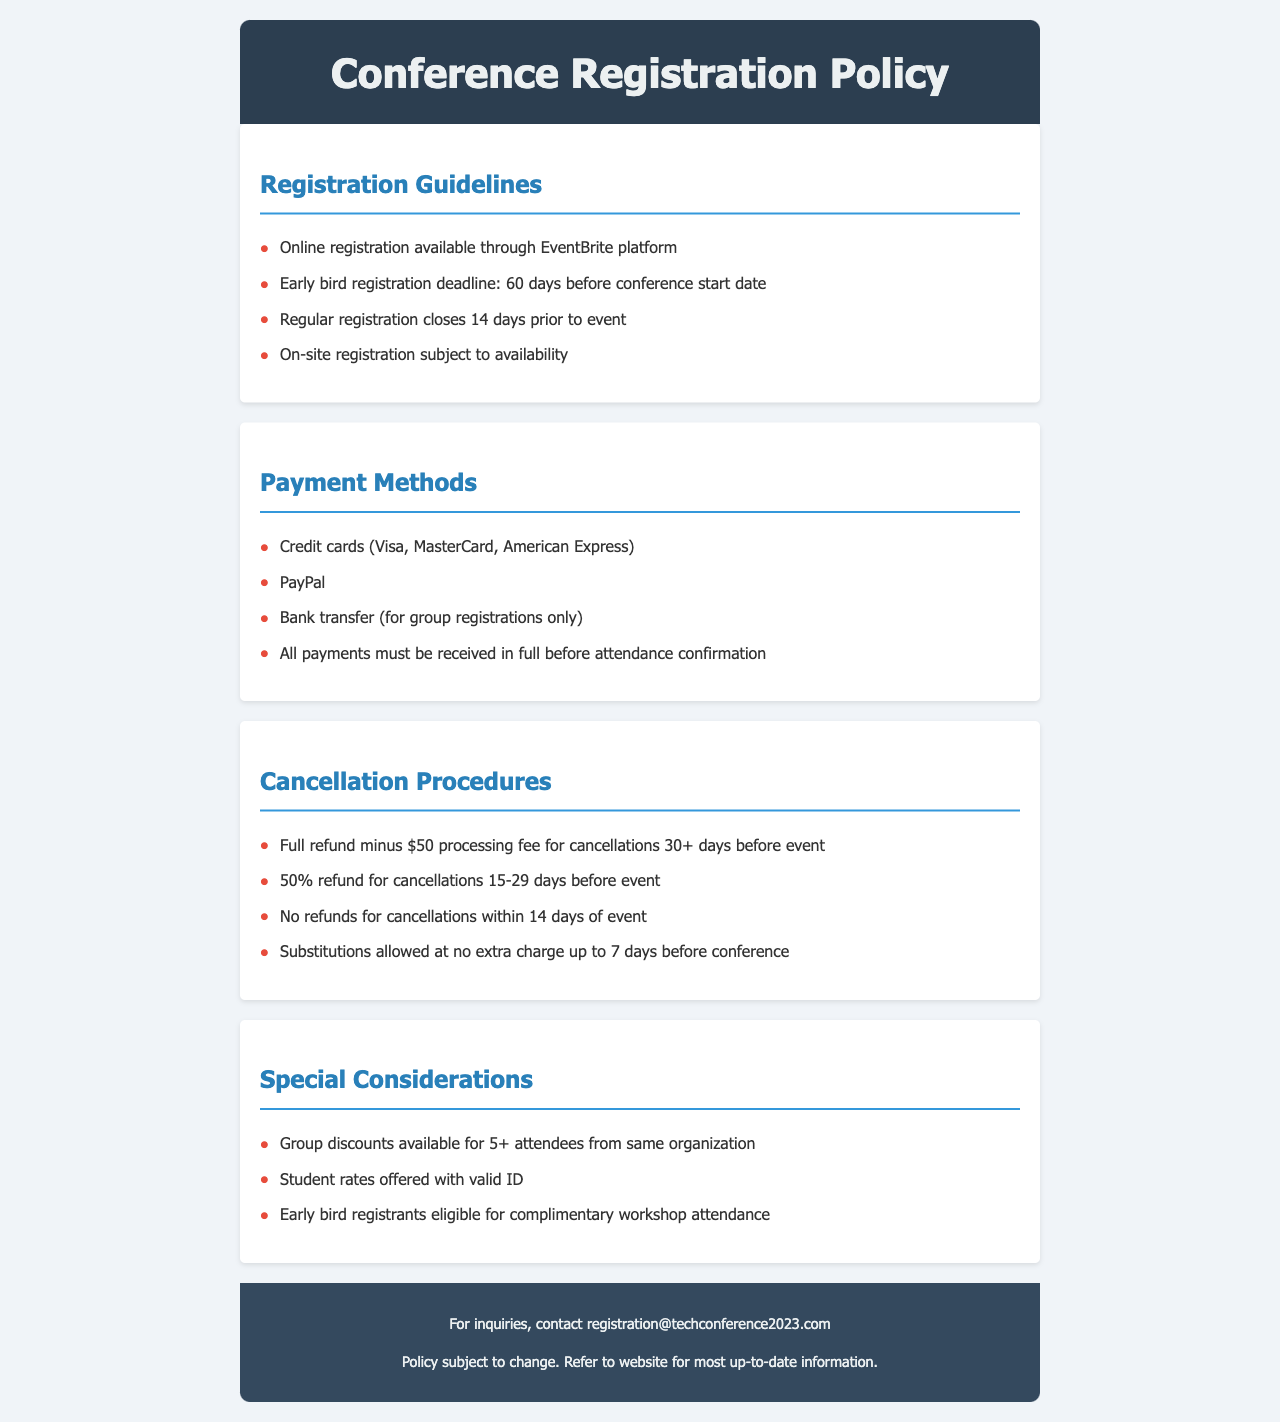what is the early bird registration deadline? The early bird registration deadline is specified as 60 days before the conference start date.
Answer: 60 days before conference start date how many days before the event does regular registration close? The document states that regular registration closes 14 days prior to the event.
Answer: 14 days which payment method is available for group registrations? The document indicates that bank transfer is an available payment method, but only for group registrations.
Answer: Bank transfer what is the refund amount for cancellations made 15-29 days before the event? The document states that for cancellations made 15-29 days before the event, a 50% refund is applicable.
Answer: 50% refund how many attendees from the same organization qualify for group discounts? The document mentions that group discounts are available for 5 or more attendees from the same organization.
Answer: 5+ what is the processing fee for cancellations made 30 or more days before the event? The document specifies that there is a $50 processing fee deducted from refunds for cancellations made 30+ days before the event.
Answer: $50 how many days before the conference are substitutions allowed? The document states that substitutions are allowed up to 7 days before the conference.
Answer: 7 days who should be contacted for inquiries regarding registration? Inquiries regarding registration should be directed to the provided email address in the footer of the document.
Answer: registration@techconference2023.com 